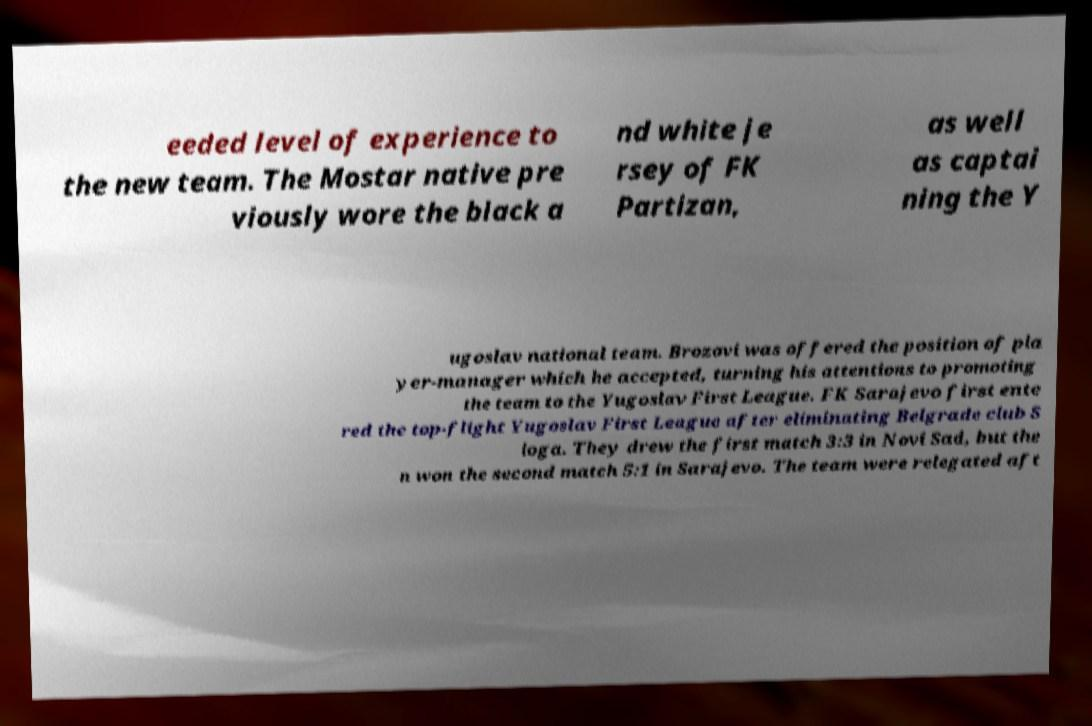Please identify and transcribe the text found in this image. eeded level of experience to the new team. The Mostar native pre viously wore the black a nd white je rsey of FK Partizan, as well as captai ning the Y ugoslav national team. Brozovi was offered the position of pla yer-manager which he accepted, turning his attentions to promoting the team to the Yugoslav First League. FK Sarajevo first ente red the top-flight Yugoslav First League after eliminating Belgrade club S loga. They drew the first match 3:3 in Novi Sad, but the n won the second match 5:1 in Sarajevo. The team were relegated aft 